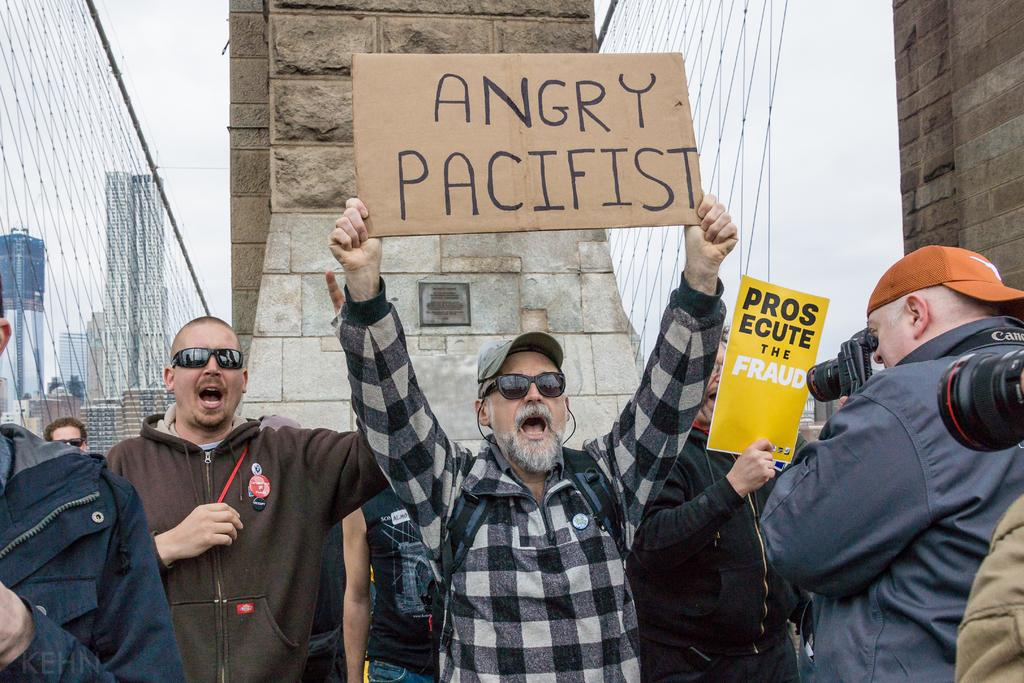Who or what is present in the image? There are people in the image. What else can be seen in the image besides the people? There are boards with text, cameras, a tank, and a fence in the image. What might the boards with text be used for? The boards with text might be used for displaying information or messages. What is the purpose of the cameras in the image? The cameras in the image might be used for recording or capturing images. How does the sheet of paper get washed in the image? There is no sheet of paper present in the image, so it cannot be washed. 